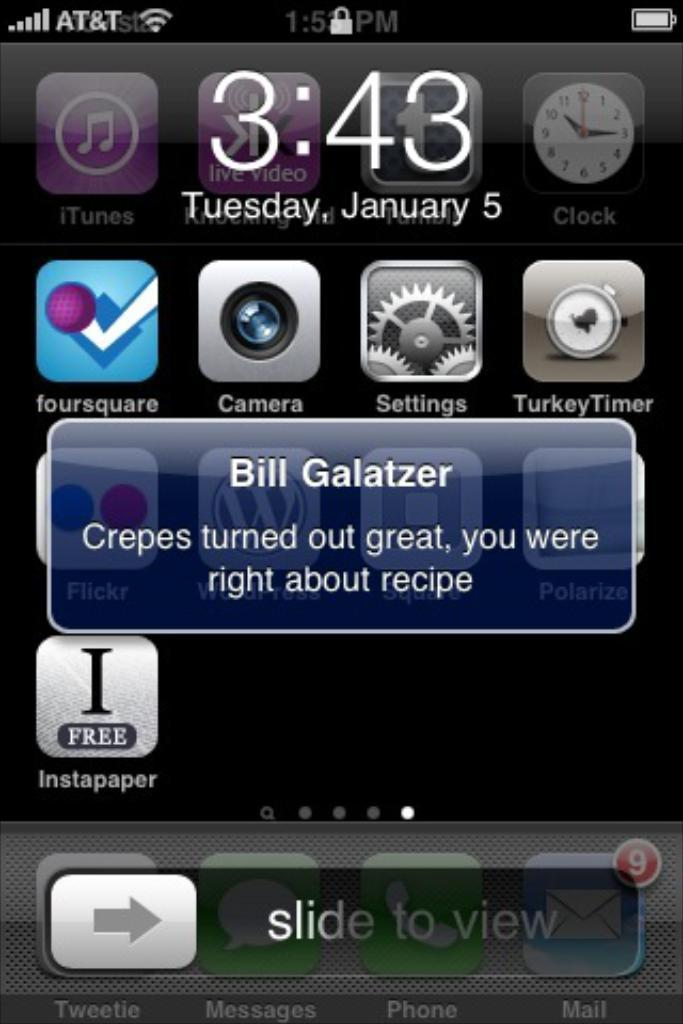<image>
Render a clear and concise summary of the photo. A phone screen displays a text message from Bill Galatzer. 